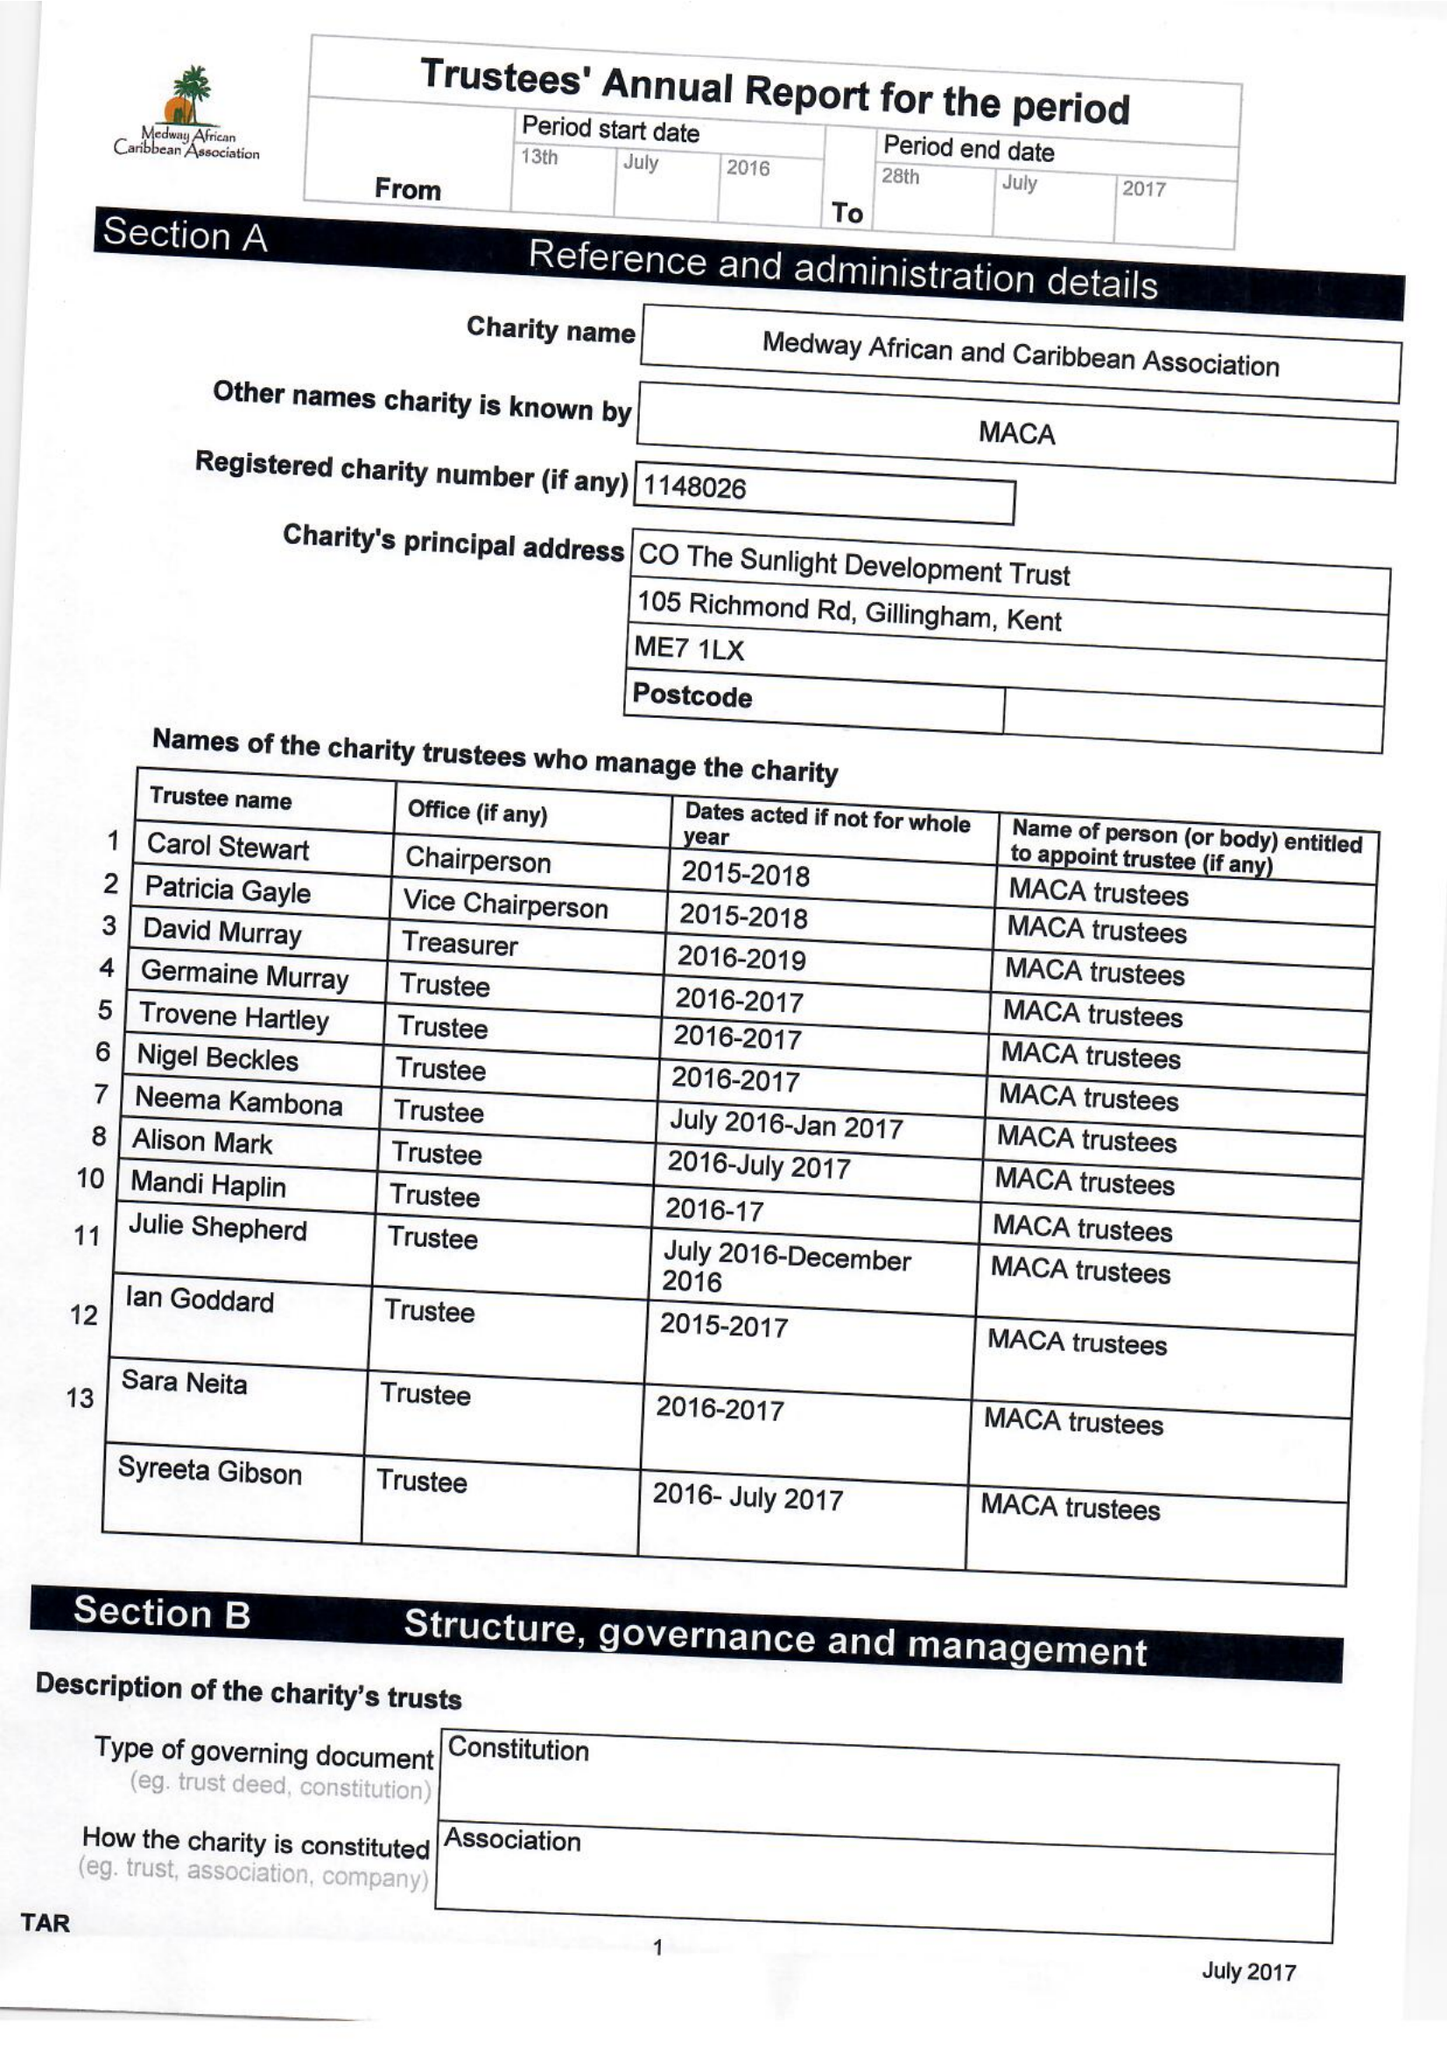What is the value for the address__postcode?
Answer the question using a single word or phrase. ME7 1LX 